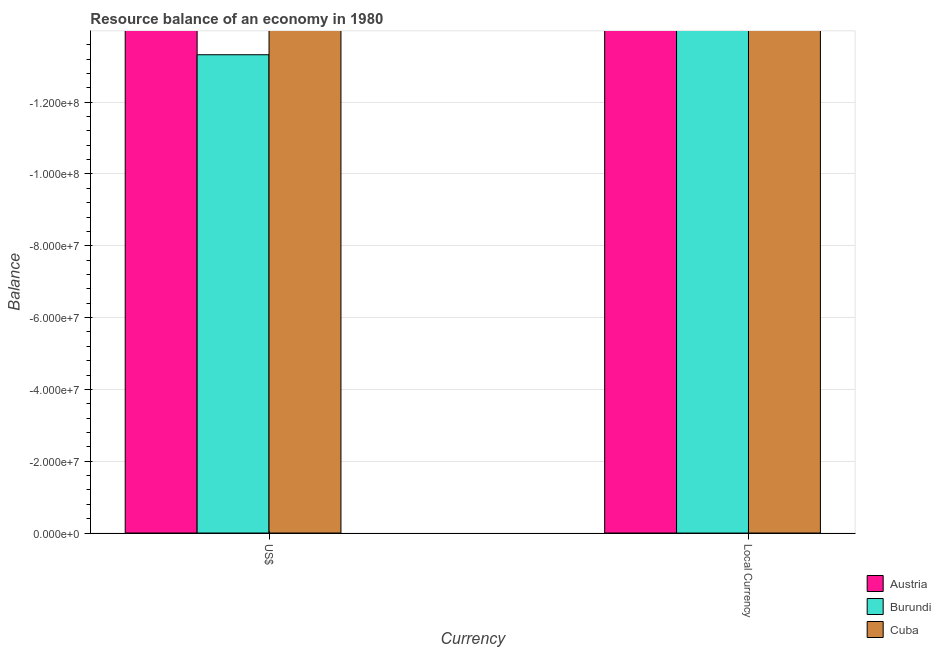How many different coloured bars are there?
Ensure brevity in your answer.  0. Are the number of bars per tick equal to the number of legend labels?
Your answer should be compact. No. Are the number of bars on each tick of the X-axis equal?
Ensure brevity in your answer.  Yes. How many bars are there on the 2nd tick from the left?
Give a very brief answer. 0. How many bars are there on the 2nd tick from the right?
Your response must be concise. 0. What is the label of the 1st group of bars from the left?
Provide a short and direct response. US$. What is the total resource balance in constant us$ in the graph?
Provide a succinct answer. 0. What is the difference between the resource balance in constant us$ in Cuba and the resource balance in us$ in Burundi?
Your answer should be very brief. 0. What is the average resource balance in constant us$ per country?
Provide a succinct answer. 0. In how many countries, is the resource balance in constant us$ greater than -28000000 units?
Make the answer very short. 0. In how many countries, is the resource balance in us$ greater than the average resource balance in us$ taken over all countries?
Your answer should be very brief. 0. Are all the bars in the graph horizontal?
Your answer should be compact. No. How many countries are there in the graph?
Your response must be concise. 3. What is the difference between two consecutive major ticks on the Y-axis?
Keep it short and to the point. 2.00e+07. Are the values on the major ticks of Y-axis written in scientific E-notation?
Keep it short and to the point. Yes. Where does the legend appear in the graph?
Give a very brief answer. Bottom right. What is the title of the graph?
Make the answer very short. Resource balance of an economy in 1980. What is the label or title of the X-axis?
Your answer should be compact. Currency. What is the label or title of the Y-axis?
Offer a very short reply. Balance. What is the Balance of Burundi in US$?
Offer a terse response. 0. What is the Balance in Cuba in US$?
Your answer should be very brief. 0. What is the Balance in Austria in Local Currency?
Offer a terse response. 0. What is the Balance in Burundi in Local Currency?
Your answer should be compact. 0. What is the Balance in Cuba in Local Currency?
Your answer should be compact. 0. What is the total Balance of Austria in the graph?
Make the answer very short. 0. What is the total Balance in Burundi in the graph?
Make the answer very short. 0. What is the total Balance in Cuba in the graph?
Your answer should be very brief. 0. What is the average Balance of Austria per Currency?
Your answer should be very brief. 0. 